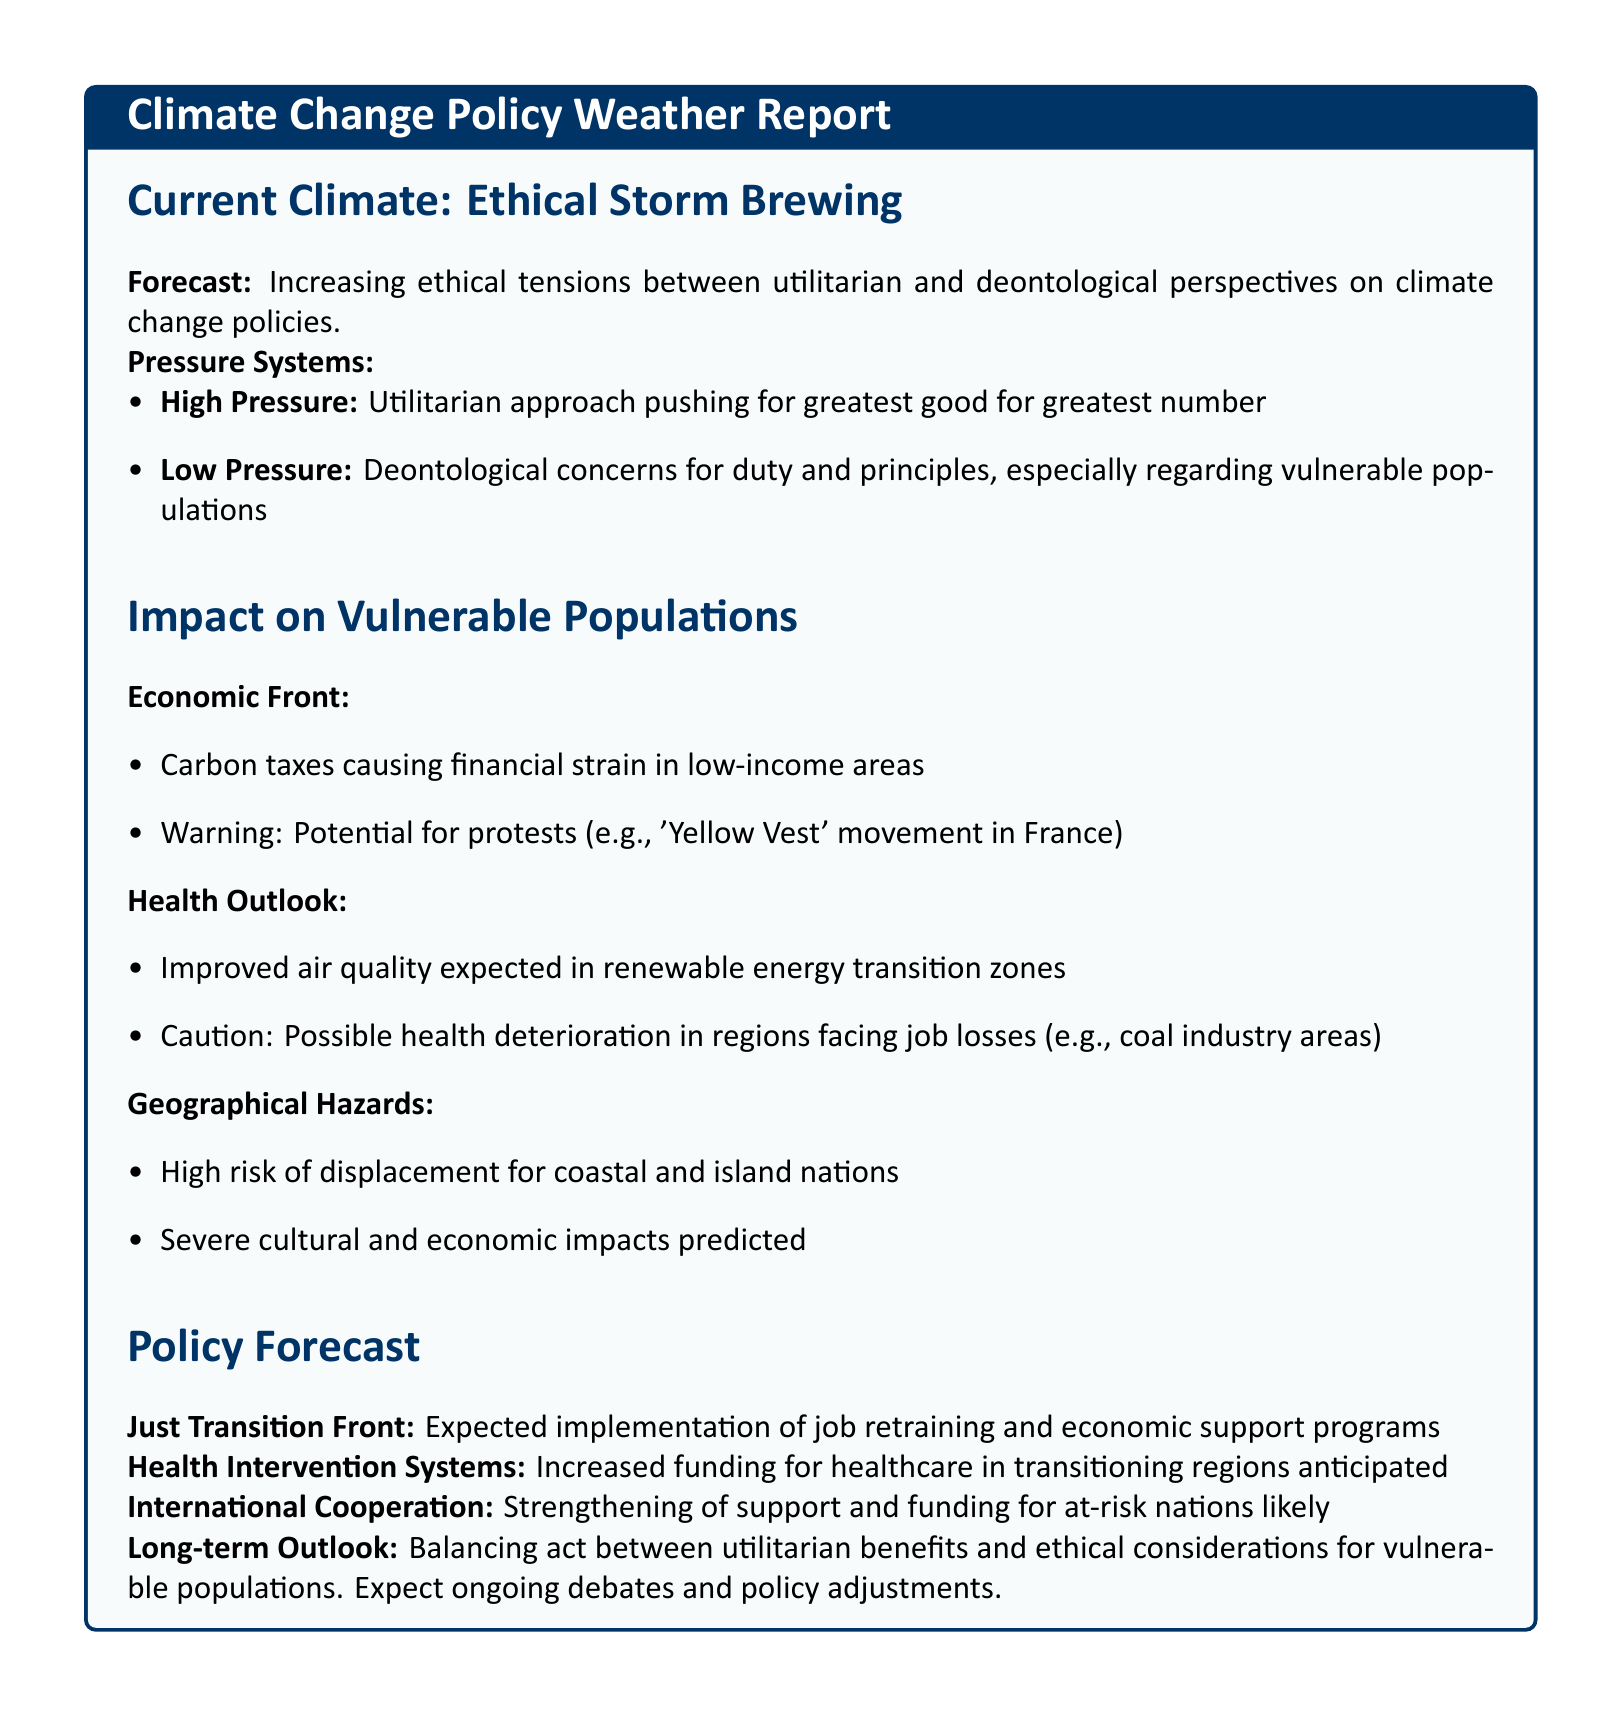What is the main ethical conflict discussed? The document describes a conflict between utilitarian and deontological perspectives regarding climate change policies.
Answer: ethical tensions What economic impact is highlighted concerning carbon taxes? The report indicates that carbon taxes cause financial strain in low-income areas.
Answer: financial strain What is the predicted effect on health in renewable energy transition zones? Improved air quality is expected in areas transitioning to renewable energy.
Answer: improved air quality Which populations are at high risk of displacement due to climate changes? Coastal and island nations are identified as populations at high risk of displacement.
Answer: coastal and island nations What type of programs are expected to be implemented for a Just Transition? The document forecasts the implementation of job retraining and economic support programs.
Answer: job retraining and economic support programs What potential movement is mentioned as a warning signal? The report references the 'Yellow Vest' movement in France as a potential warning signal.
Answer: 'Yellow Vest' movement What long-term outcome is anticipated regarding policy adjustments? Ongoing debates and policy adjustments are expected as stakeholders balance ethical considerations.
Answer: ongoing debates What type of funding is anticipated for healthcare in transitioning regions? Increased funding for healthcare in transitioning regions is anticipated.
Answer: increased funding 